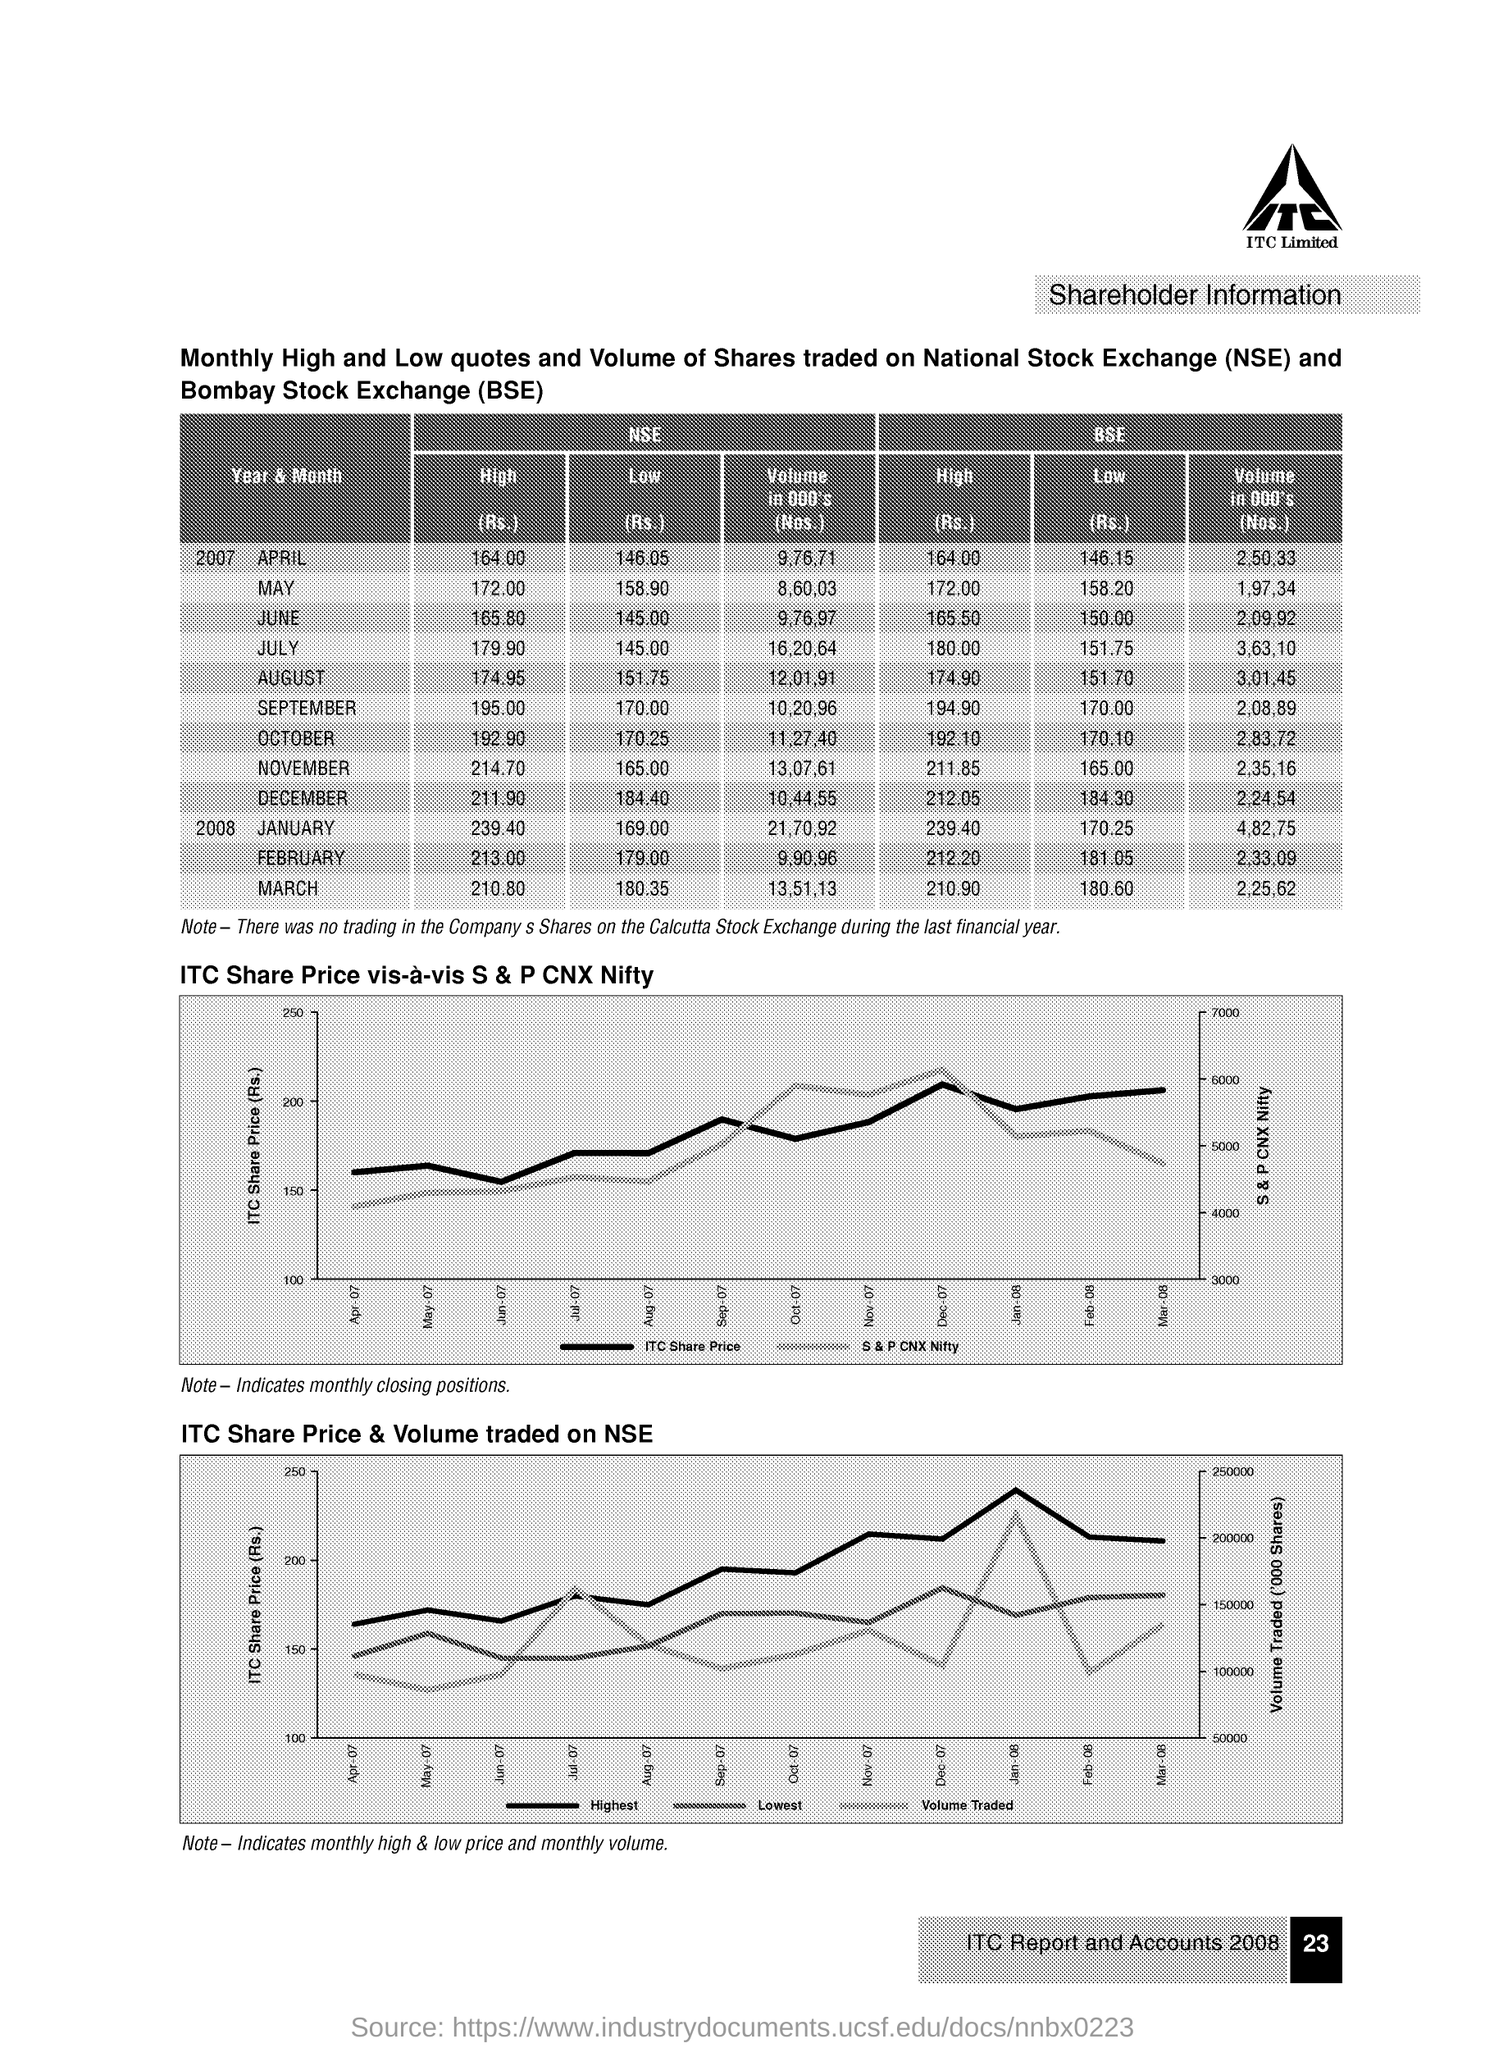Draw attention to some important aspects in this diagram. The second graph on the page shows the ITC share price and the volume of trading that took place on the National Stock Exchange (NSE). 